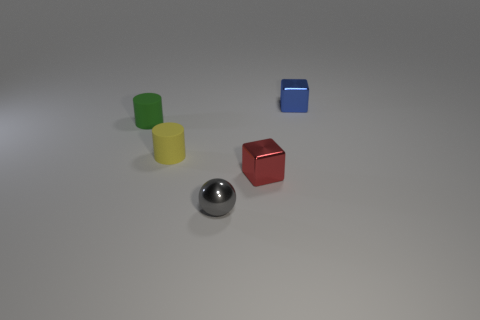What number of other objects are the same color as the metallic sphere?
Ensure brevity in your answer.  0. Is the number of small green rubber cylinders to the right of the green matte cylinder less than the number of small green matte objects?
Give a very brief answer. Yes. How many big green metal cubes are there?
Your answer should be very brief. 0. What number of blue objects have the same material as the small green thing?
Ensure brevity in your answer.  0. What number of objects are tiny green rubber objects to the left of the tiny yellow cylinder or cylinders?
Offer a terse response. 2. Is the number of tiny yellow matte objects that are to the right of the small blue object less than the number of tiny blue cubes that are in front of the small green thing?
Offer a very short reply. No. There is a tiny green matte cylinder; are there any balls behind it?
Provide a short and direct response. No. What number of things are either small matte cylinders that are right of the green object or things to the right of the yellow thing?
Your answer should be compact. 4. What number of objects are the same color as the metal sphere?
Offer a very short reply. 0. The other small rubber object that is the same shape as the green thing is what color?
Ensure brevity in your answer.  Yellow. 